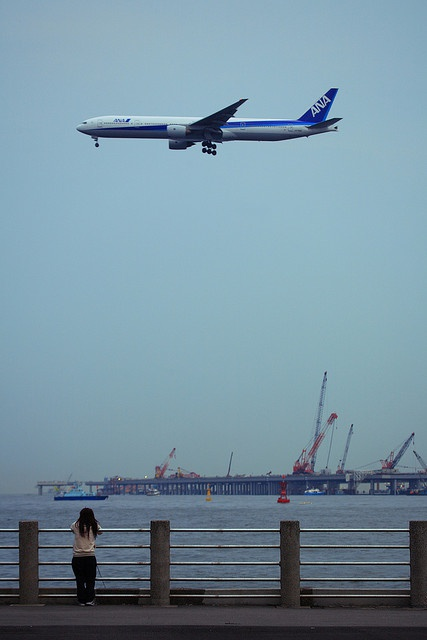Describe the objects in this image and their specific colors. I can see airplane in darkgray, navy, black, and lightblue tones, people in darkgray, black, and gray tones, boat in darkgray, navy, and gray tones, and boat in darkgray, gray, and darkblue tones in this image. 